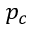<formula> <loc_0><loc_0><loc_500><loc_500>p _ { c }</formula> 